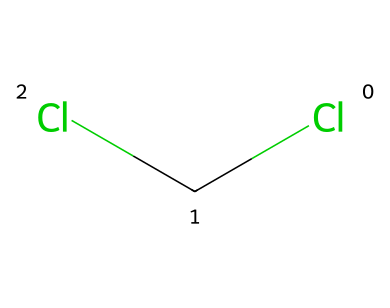What is the common name of this chemical? The SMILES representation ClCCl corresponds to the structure of dichloromethane. This name is commonly used in chemical literature and industry.
Answer: dichloromethane How many chlorine atoms are present in the molecule? Analyzing the SMILES representation shows that there are two "Cl" symbols indicating the presence of two chlorine atoms bonded to the central carbon atom.
Answer: two What type of solvent is dichloromethane classified as? Dichloromethane is known as a nonpolar solvent due to its molecular structure and low polarity, which allows it to dissolve various organic compounds.
Answer: nonpolar What is the molecular formula of dichloromethane? The SMILES representation indicates one carbon atom and two chlorine atoms, leading to the molecular formula of CH2Cl2, which shows the ratio of elements in the compound.
Answer: CH2Cl2 What type of interaction is primarily used for extraction in decaffeination with dichloromethane? Dichloromethane exhibits the ability to dissolve caffeine through dipole-dipole interactions due to the polar nature of chlorine and the nonpolar carbon.
Answer: dipole-dipole interactions What is the primary physical state of dichloromethane at room temperature? Knowing that dichloromethane has a relatively low boiling point (39.6°C), we can conclude that at room temperature (around 20°C), it is a liquid.
Answer: liquid 